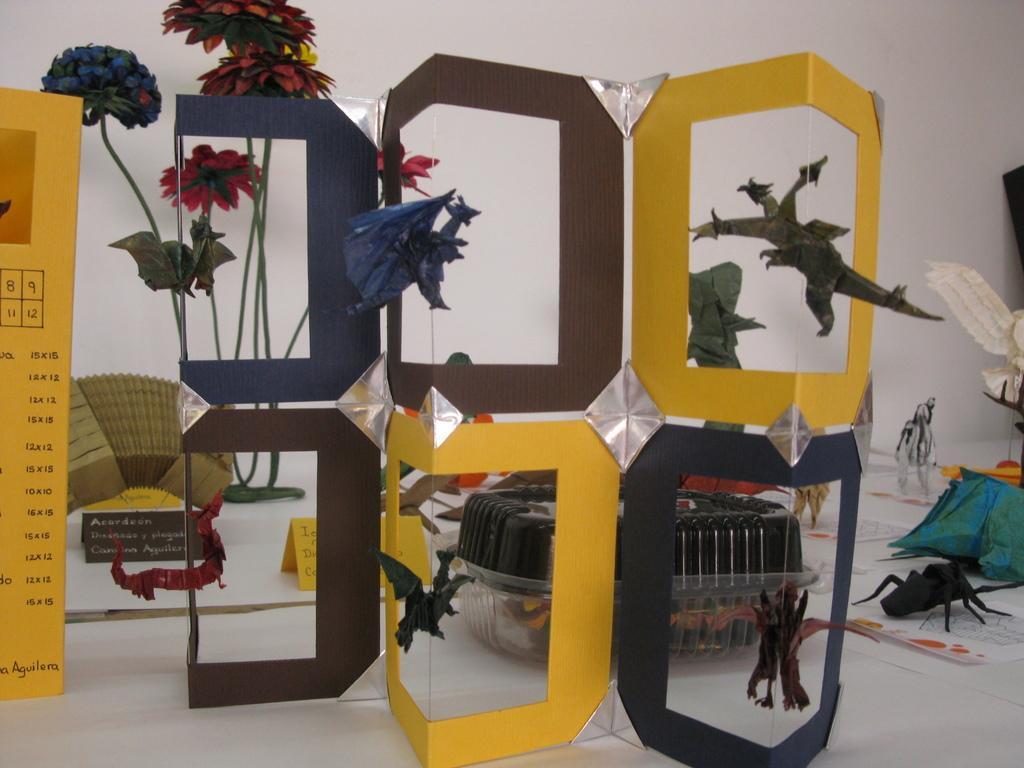Could you give a brief overview of what you see in this image? In this image we can see art made with papers and we can also see flowers. 